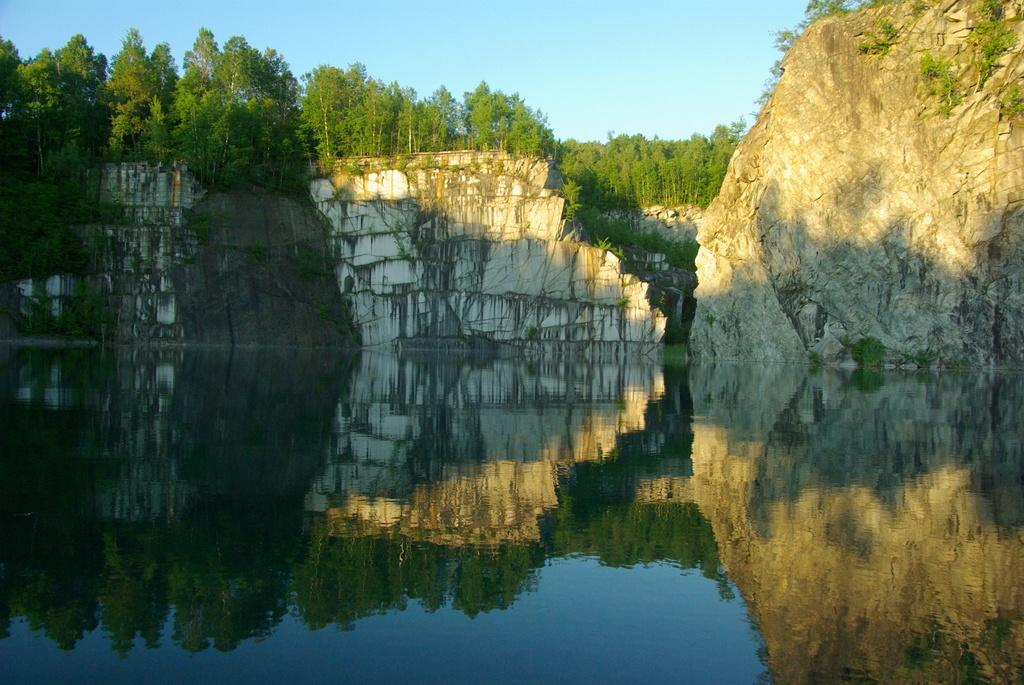What can be seen on the water's surface in the image? There are reflections of trees and other objects on the water. What type of structures are visible in the image? There are walls visible in the image. What natural element is present in the image? There is a rock in the image. What type of vegetation is present in the image? Trees are present in the image. What part of the natural environment is visible in the image? The sky is visible in the image. What type of hammer is being used to hit the doll in the image? There is no hammer, doll, or any such activity present in the image. 